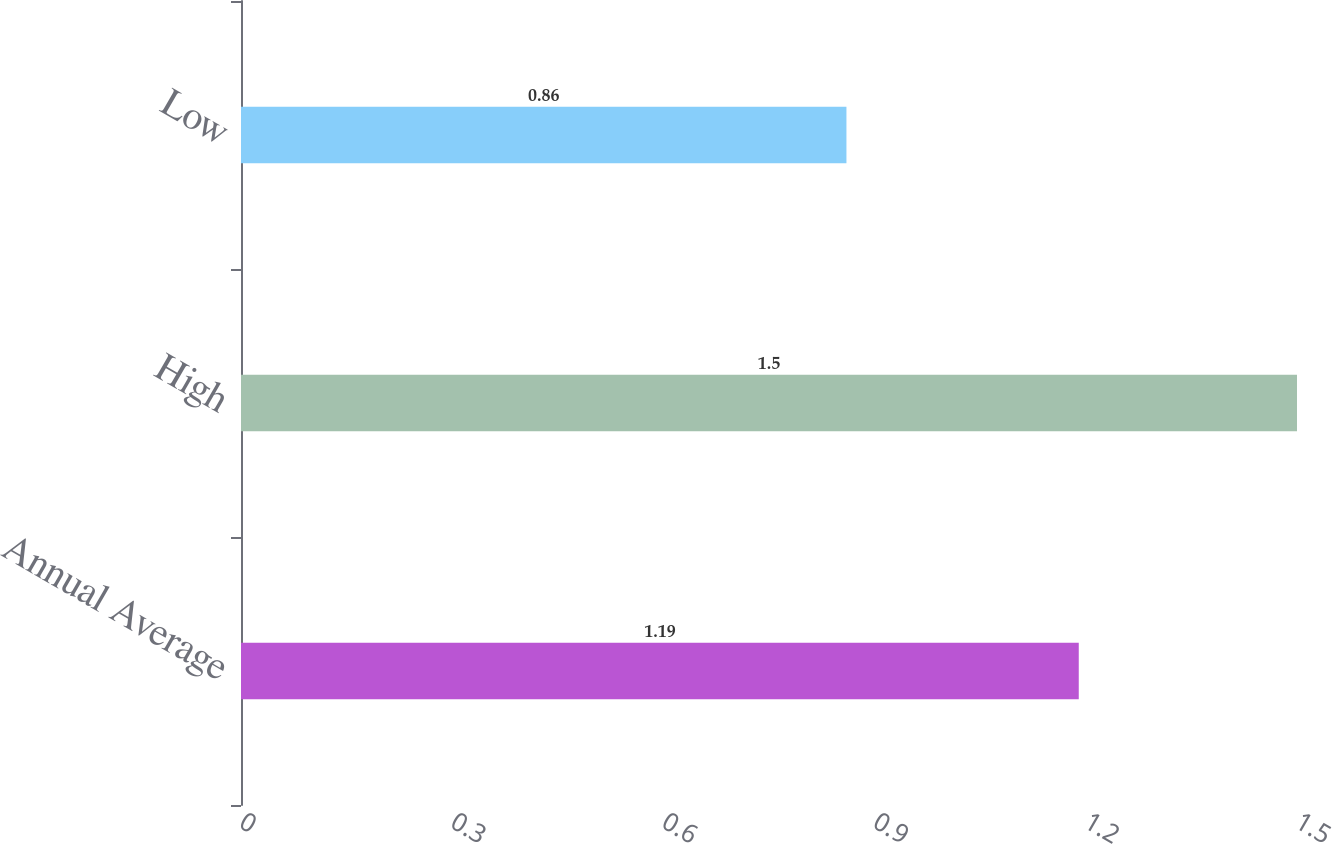Convert chart to OTSL. <chart><loc_0><loc_0><loc_500><loc_500><bar_chart><fcel>Annual Average<fcel>High<fcel>Low<nl><fcel>1.19<fcel>1.5<fcel>0.86<nl></chart> 